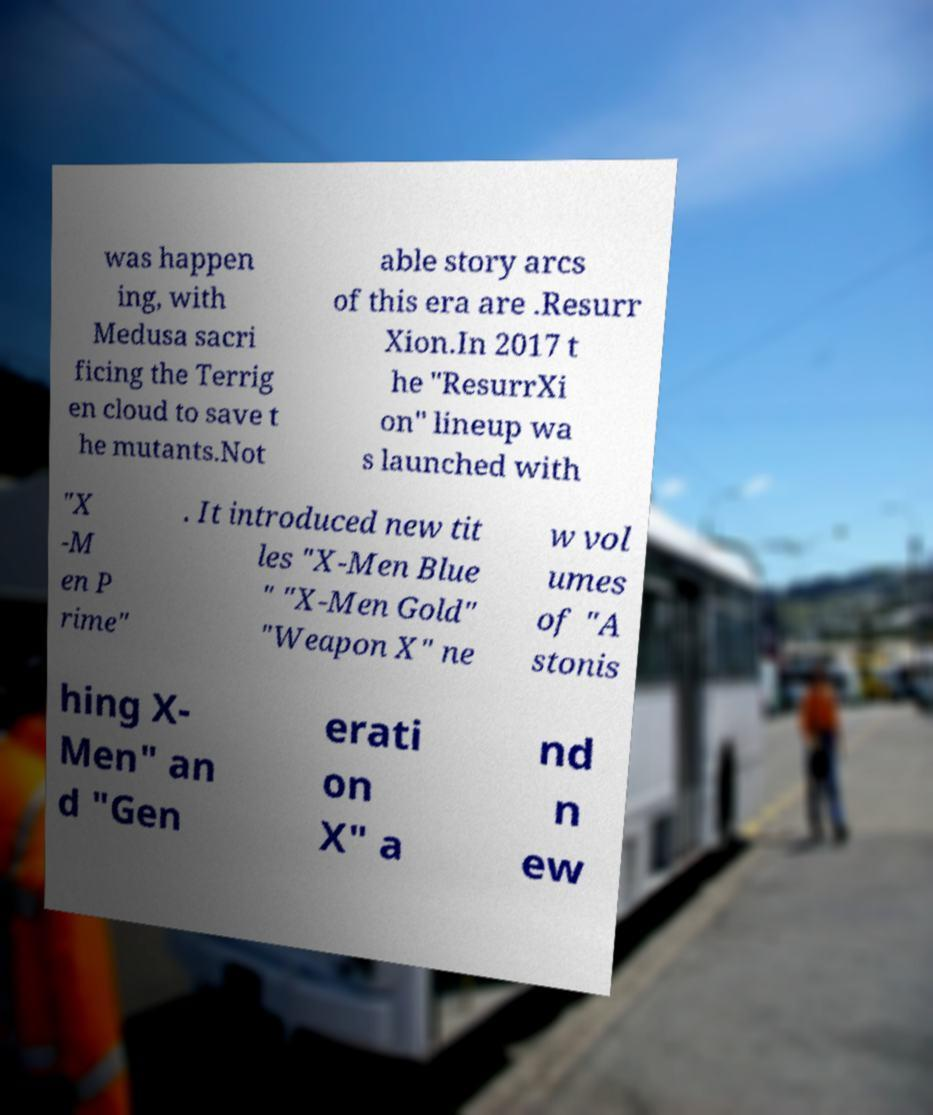Please read and relay the text visible in this image. What does it say? was happen ing, with Medusa sacri ficing the Terrig en cloud to save t he mutants.Not able story arcs of this era are .Resurr Xion.In 2017 t he "ResurrXi on" lineup wa s launched with "X -M en P rime" . It introduced new tit les "X-Men Blue " "X-Men Gold" "Weapon X" ne w vol umes of "A stonis hing X- Men" an d "Gen erati on X" a nd n ew 